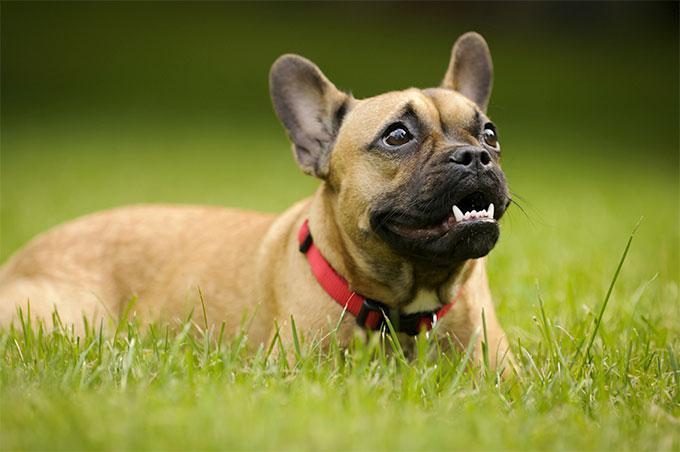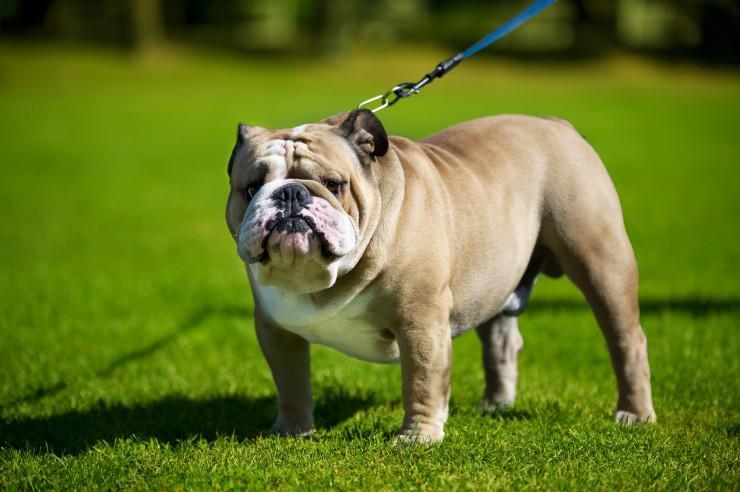The first image is the image on the left, the second image is the image on the right. For the images displayed, is the sentence "Two small dogs with ears standing up have no collar or leash." factually correct? Answer yes or no. No. 